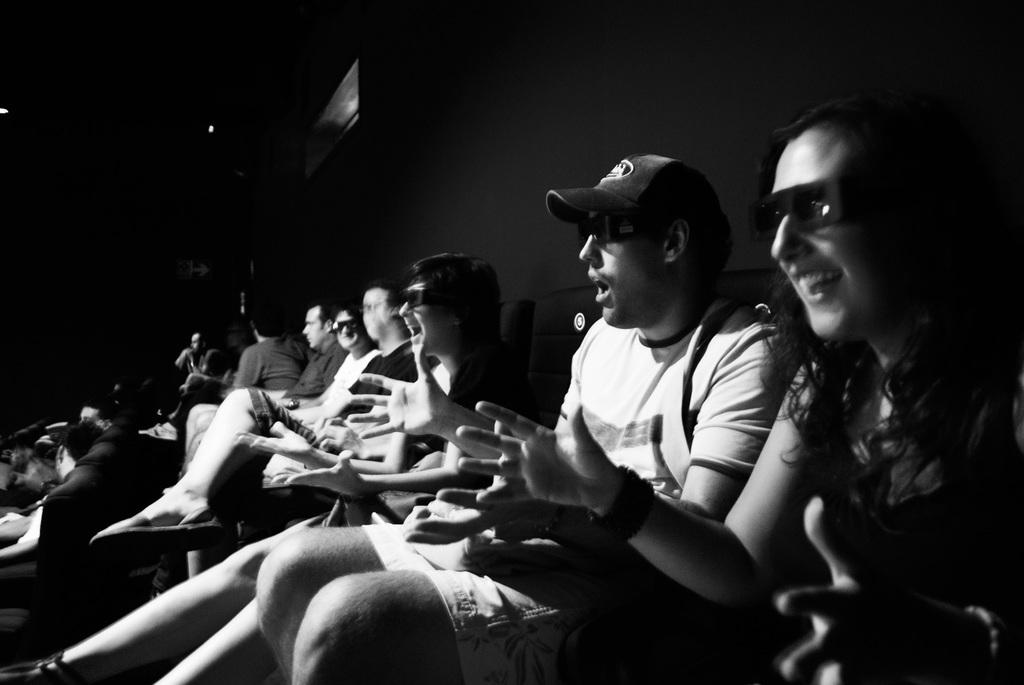What is the color scheme of the image? The image is black and white. What are the people in the image doing? People are sitting on chairs in the image. What protective gear are some people wearing? Some people are wearing goggles. Can you describe the clothing of one of the men in the image? One man is wearing a cap. How many mice are running around on the chairs in the image? There are no mice present in the image; it features people sitting on chairs. What type of form or trade is being conducted in the image? There is no indication of any form or trade being conducted in the image. 